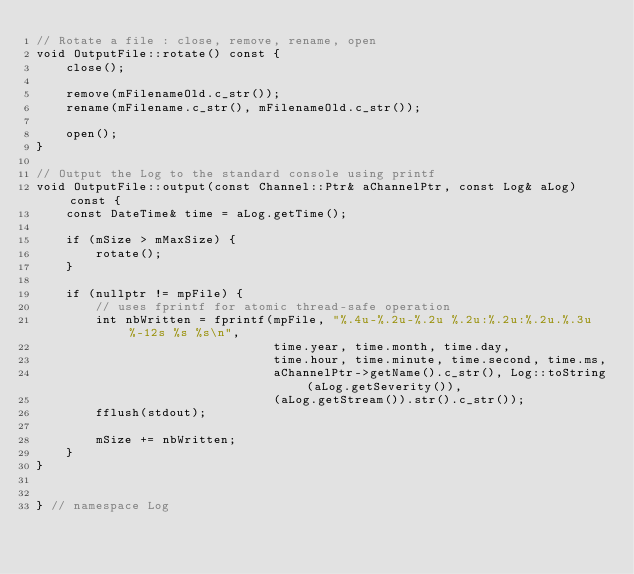<code> <loc_0><loc_0><loc_500><loc_500><_C++_>// Rotate a file : close, remove, rename, open
void OutputFile::rotate() const {
    close();

    remove(mFilenameOld.c_str());
    rename(mFilename.c_str(), mFilenameOld.c_str());

    open();
}

// Output the Log to the standard console using printf
void OutputFile::output(const Channel::Ptr& aChannelPtr, const Log& aLog) const {
    const DateTime& time = aLog.getTime();

    if (mSize > mMaxSize) {
        rotate();
    }

    if (nullptr != mpFile) {
        // uses fprintf for atomic thread-safe operation
        int nbWritten = fprintf(mpFile, "%.4u-%.2u-%.2u %.2u:%.2u:%.2u.%.3u  %-12s %s %s\n",
                                time.year, time.month, time.day,
                                time.hour, time.minute, time.second, time.ms,
                                aChannelPtr->getName().c_str(), Log::toString(aLog.getSeverity()),
                                (aLog.getStream()).str().c_str());
        fflush(stdout);

        mSize += nbWritten;
    }
}


} // namespace Log
</code> 